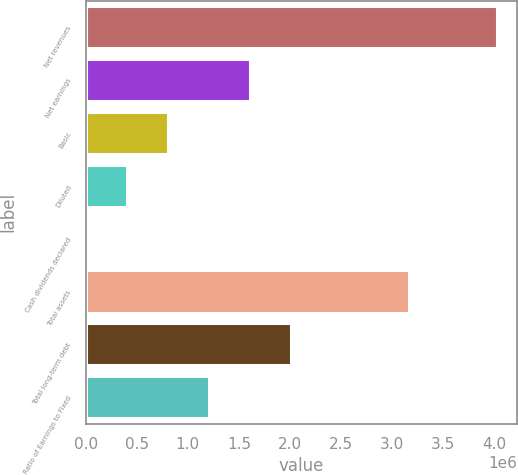Convert chart to OTSL. <chart><loc_0><loc_0><loc_500><loc_500><bar_chart><fcel>Net revenues<fcel>Net earnings<fcel>Basic<fcel>Diluted<fcel>Cash dividends declared<fcel>Total assets<fcel>Total long-term debt<fcel>Ratio of Earnings to Fixed<nl><fcel>4.02152e+06<fcel>1.60861e+06<fcel>804305<fcel>402153<fcel>0.8<fcel>3.1688e+06<fcel>2.01076e+06<fcel>1.20646e+06<nl></chart> 